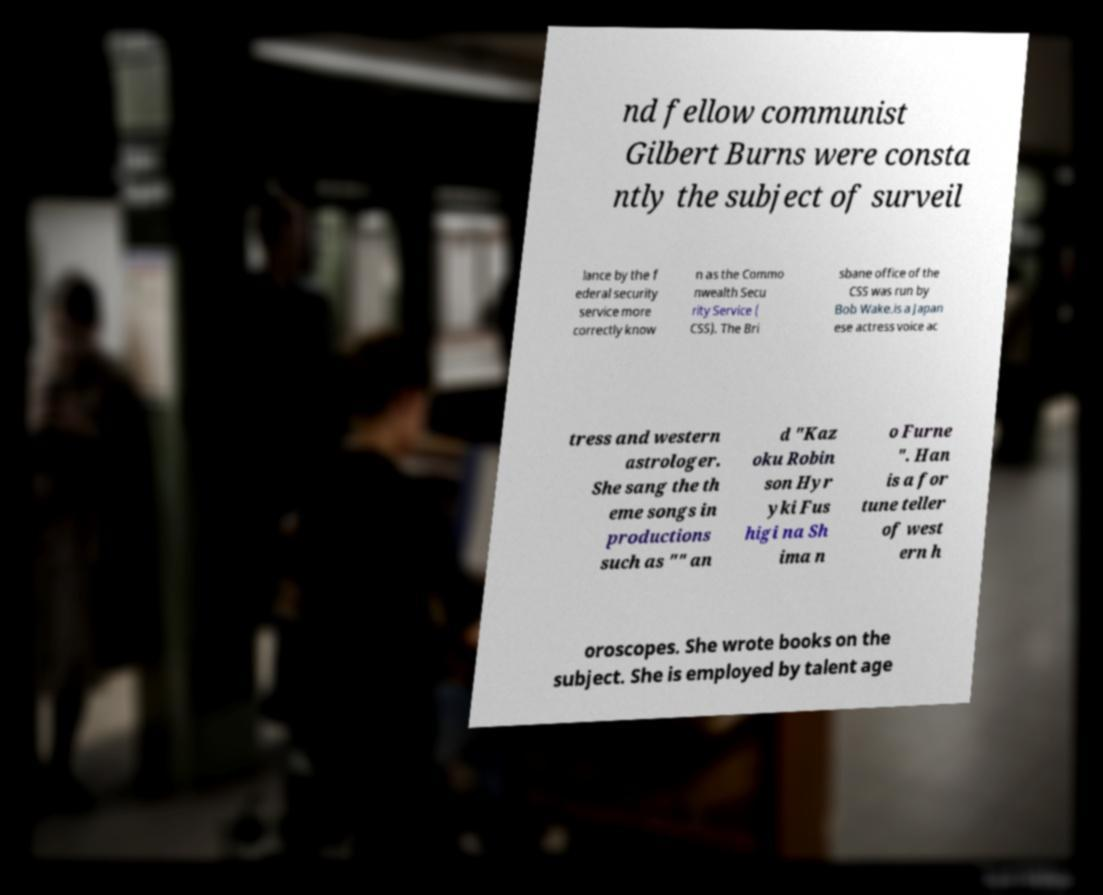For documentation purposes, I need the text within this image transcribed. Could you provide that? nd fellow communist Gilbert Burns were consta ntly the subject of surveil lance by the f ederal security service more correctly know n as the Commo nwealth Secu rity Service ( CSS). The Bri sbane office of the CSS was run by Bob Wake.is a Japan ese actress voice ac tress and western astrologer. She sang the th eme songs in productions such as "" an d "Kaz oku Robin son Hyr yki Fus higi na Sh ima n o Furne ". Han is a for tune teller of west ern h oroscopes. She wrote books on the subject. She is employed by talent age 